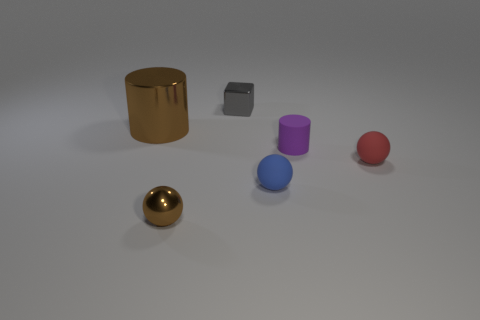Subtract all small brown spheres. How many spheres are left? 2 Add 1 tiny purple cylinders. How many objects exist? 7 Subtract all blocks. How many objects are left? 5 Subtract 0 gray cylinders. How many objects are left? 6 Subtract all shiny things. Subtract all small brown metallic balls. How many objects are left? 2 Add 6 matte balls. How many matte balls are left? 8 Add 6 small red objects. How many small red objects exist? 7 